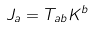Convert formula to latex. <formula><loc_0><loc_0><loc_500><loc_500>J _ { a } = T _ { a b } K ^ { b }</formula> 